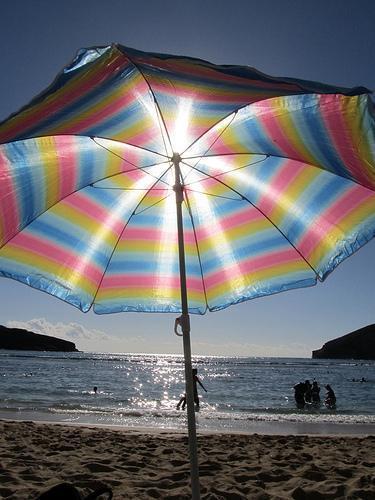How many umbrella's are there?
Give a very brief answer. 1. How many segments are on the umbrella?
Give a very brief answer. 8. 